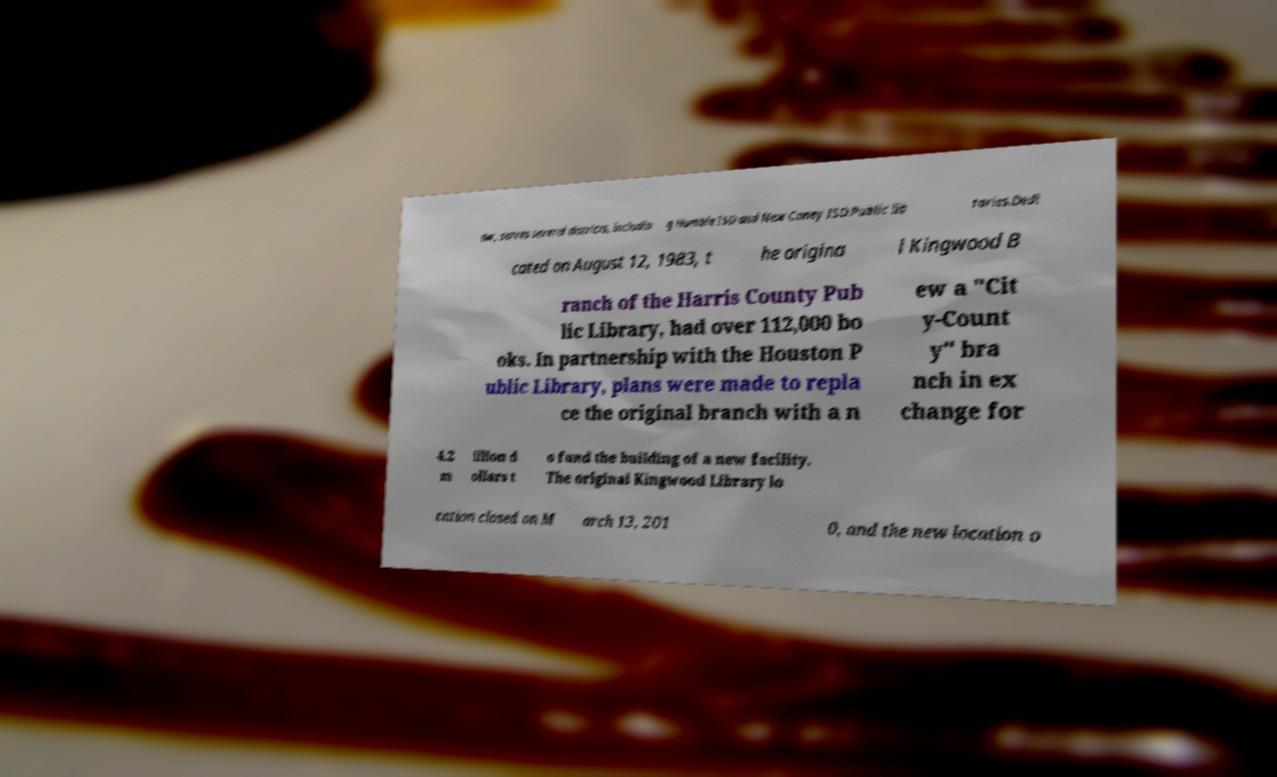Please identify and transcribe the text found in this image. aw, serves several districts, includin g Humble ISD and New Caney ISD.Public lib raries.Dedi cated on August 12, 1983, t he origina l Kingwood B ranch of the Harris County Pub lic Library, had over 112,000 bo oks. In partnership with the Houston P ublic Library, plans were made to repla ce the original branch with a n ew a "Cit y-Count y" bra nch in ex change for 4.2 m illion d ollars t o fund the building of a new facility. The original Kingwood Library lo cation closed on M arch 13, 201 0, and the new location o 